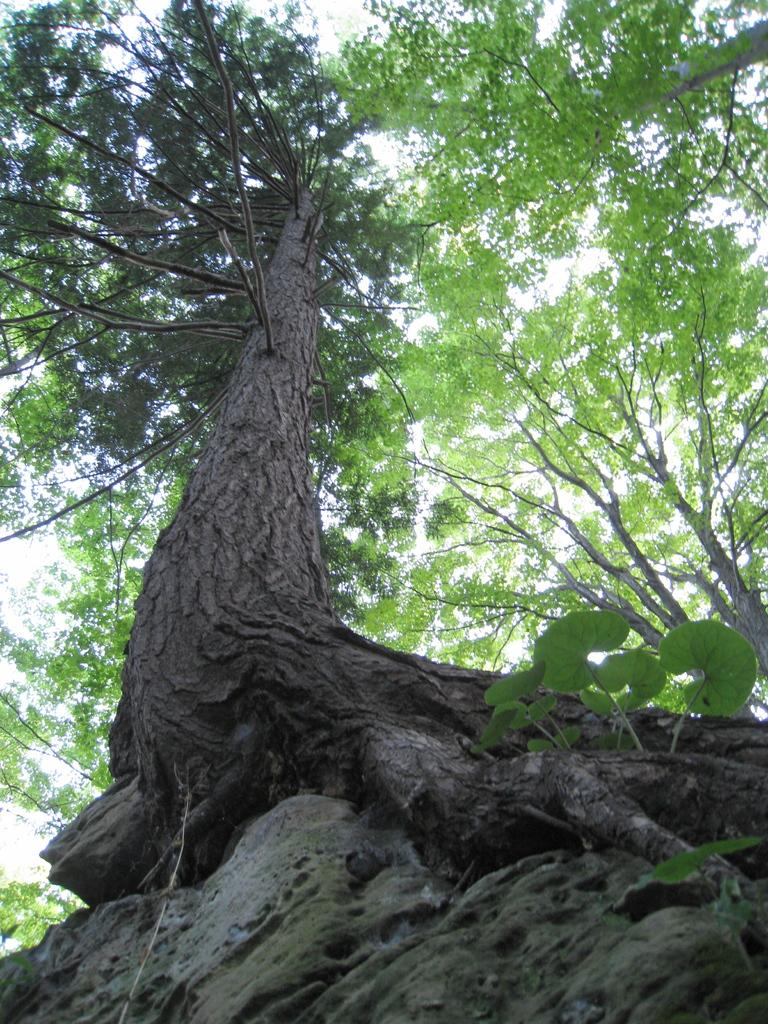What type of vegetation can be seen in the image? There are trees in the image. What specific features of the trees are visible? Leaves and branches are visible on the trees. What vegetables are being listed in the image? There are no vegetables or lists present in the image; it features trees with leaves and branches. 